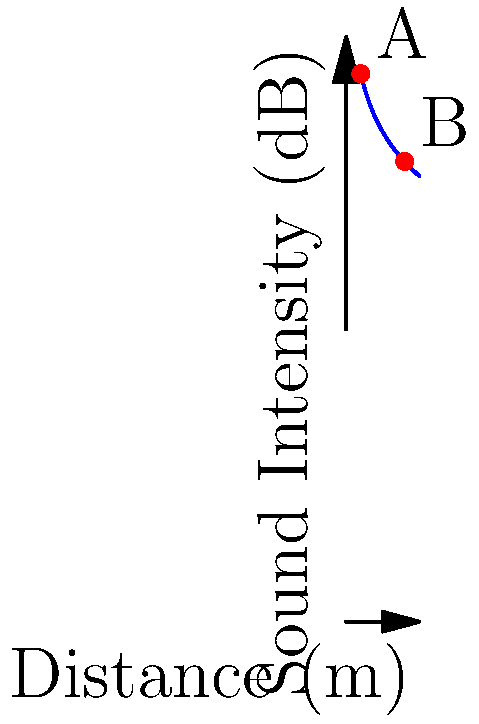In the Royal Opera of Versailles, the sound intensity level at point A, 2 meters from the stage, is measured at 75 dB. Using the graph, estimate the sound intensity level at point B, 8 meters from the stage. What physical principle explains this change in sound intensity? To answer this question, we need to follow these steps:

1. Understand the inverse square law for sound intensity:
   The sound intensity decreases proportionally to the square of the distance from the source.

2. Interpret the graph:
   The blue curve represents the sound intensity level as a function of distance from the stage.

3. Locate points A and B:
   Point A is at (2m, 75dB)
   Point B is at (8m, 63dB)

4. Calculate the change in distance:
   The distance increases from 2m to 8m, which is a factor of 4.

5. Apply the inverse square law:
   When distance increases by a factor of 4, intensity should decrease by a factor of $4^2 = 16$.

6. Convert intensity ratio to decibels:
   Change in dB = $10 \log_{10}(1/16) = -12$ dB

7. Verify with the graph:
   The graph shows a decrease from 75 dB to 63 dB, which is indeed 12 dB.

The physical principle explaining this change is the inverse square law for sound intensity. As sound waves spread out from a point source, the energy is distributed over an ever-increasing area, resulting in a decrease in intensity proportional to the square of the distance from the source.
Answer: 63 dB; inverse square law 